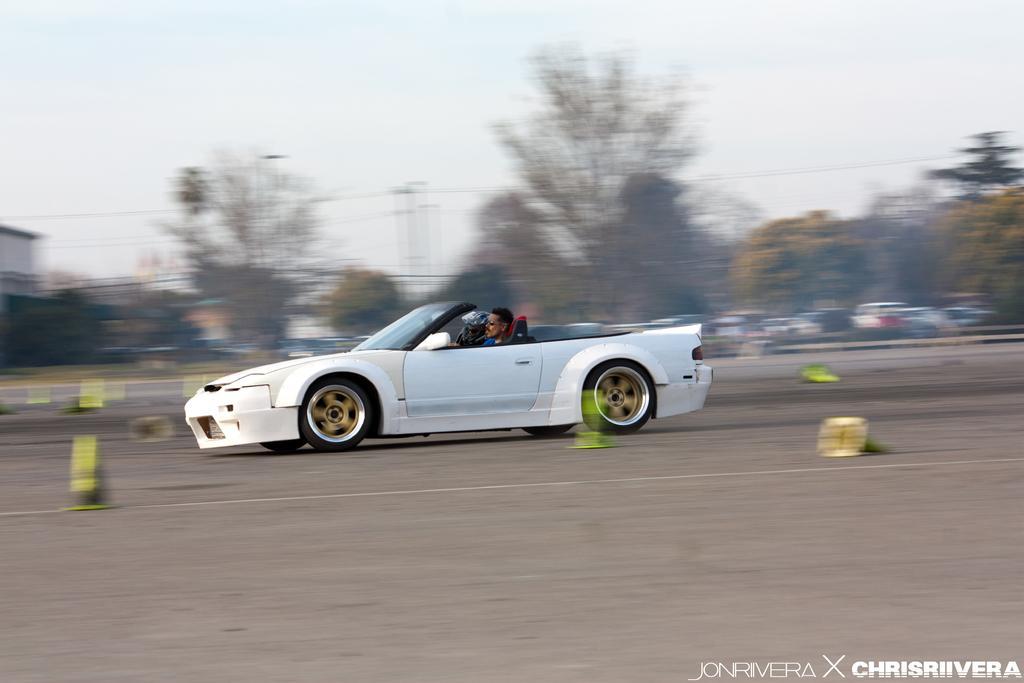How would you summarize this image in a sentence or two? In this image, there are a few vehicles. Among them, we can see a car with some people. We can see the ground with some objects. There are a few trees, poles with wires. We can see the sky. 